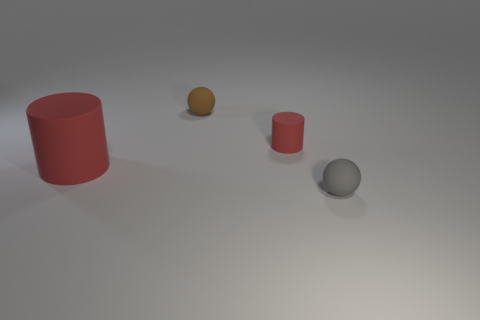How many large red cylinders have the same material as the tiny cylinder?
Your response must be concise. 1. Is the ball that is in front of the brown sphere made of the same material as the brown thing?
Give a very brief answer. Yes. Are there more balls left of the brown thing than small matte objects to the left of the small gray rubber sphere?
Your response must be concise. No. There is another sphere that is the same size as the brown rubber ball; what is it made of?
Provide a succinct answer. Rubber. What number of other things are made of the same material as the big red object?
Ensure brevity in your answer.  3. Does the large red object that is behind the tiny gray sphere have the same shape as the tiny object to the left of the small red cylinder?
Provide a short and direct response. No. How many other things are there of the same color as the large matte cylinder?
Keep it short and to the point. 1. Are the tiny sphere that is in front of the brown rubber ball and the ball that is behind the gray sphere made of the same material?
Make the answer very short. Yes. Is the number of small cylinders that are behind the brown ball the same as the number of spheres behind the tiny gray thing?
Ensure brevity in your answer.  No. There is a cylinder that is to the right of the large red matte object; what is its material?
Give a very brief answer. Rubber. 